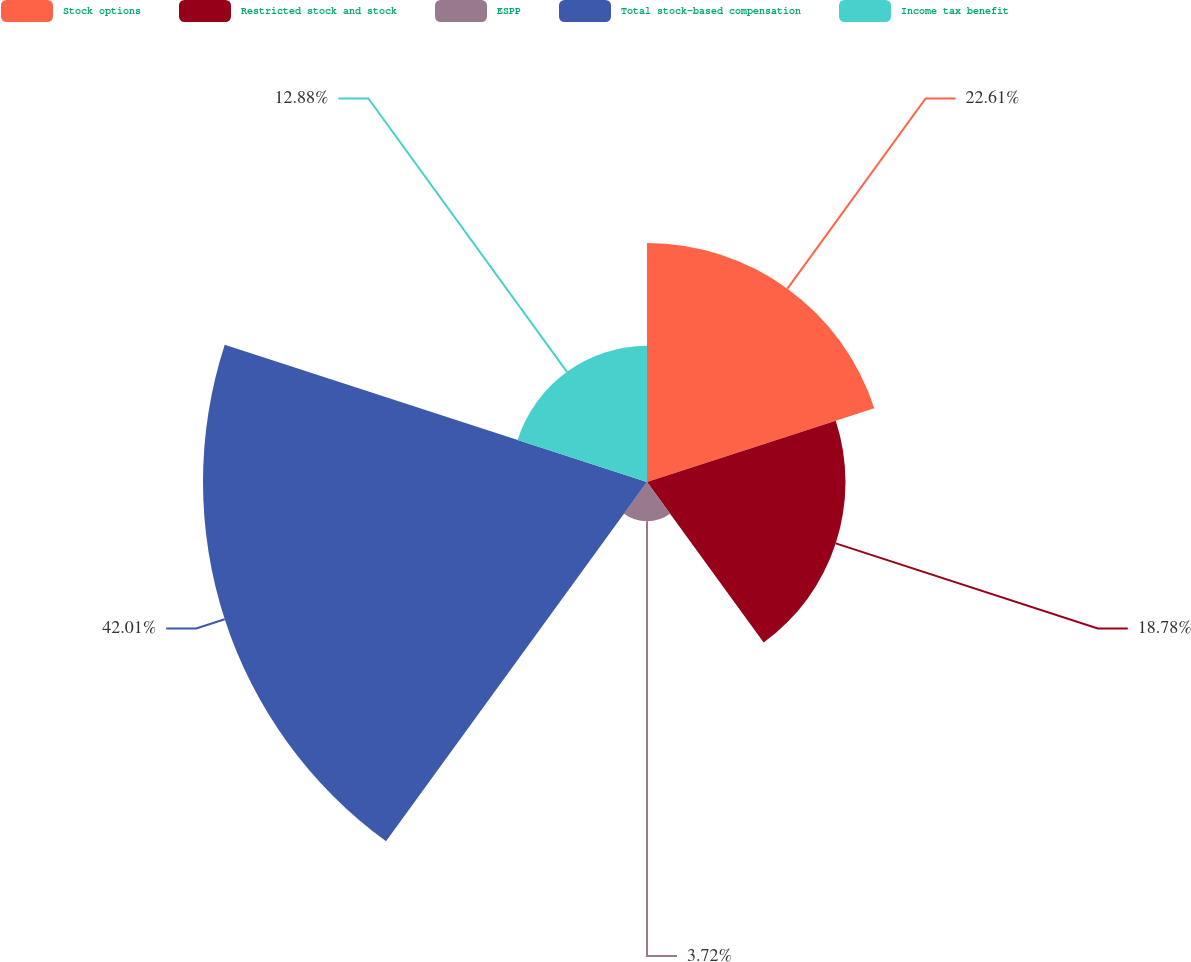Convert chart to OTSL. <chart><loc_0><loc_0><loc_500><loc_500><pie_chart><fcel>Stock options<fcel>Restricted stock and stock<fcel>ESPP<fcel>Total stock-based compensation<fcel>Income tax benefit<nl><fcel>22.61%<fcel>18.78%<fcel>3.72%<fcel>42.01%<fcel>12.88%<nl></chart> 